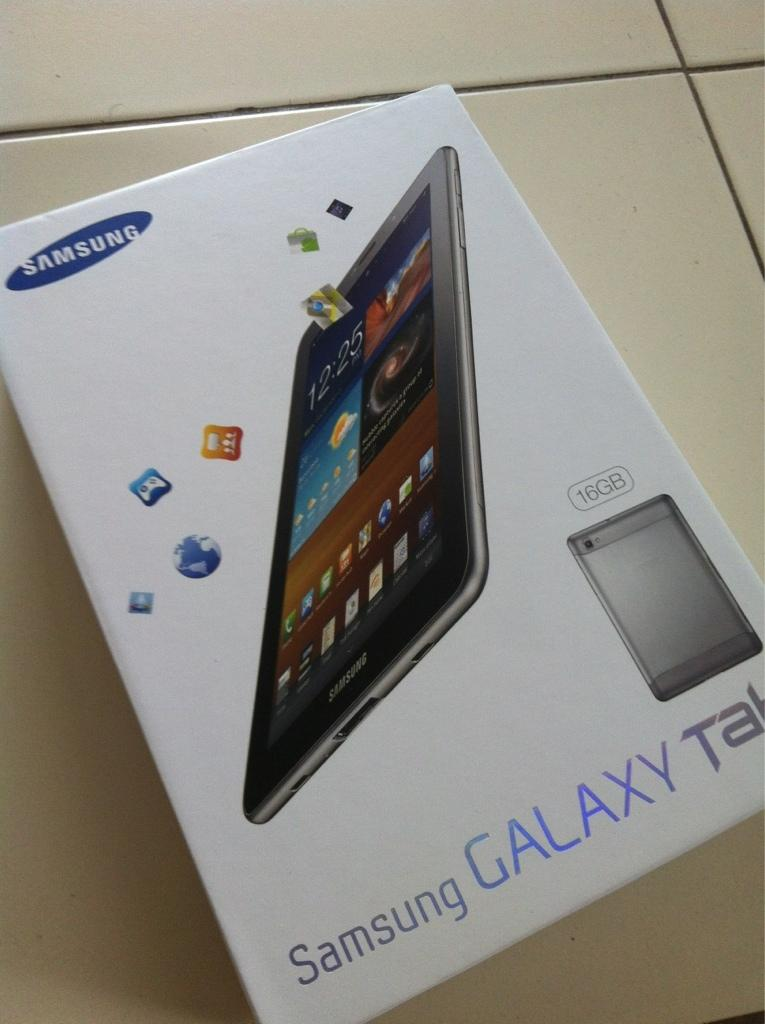What object can be seen in the image? There is a box in the image. Where is the box located? The box is placed on the floor. How many bears are sitting on the box in the image? There are no bears present in the image; it only features a box placed on the floor. 